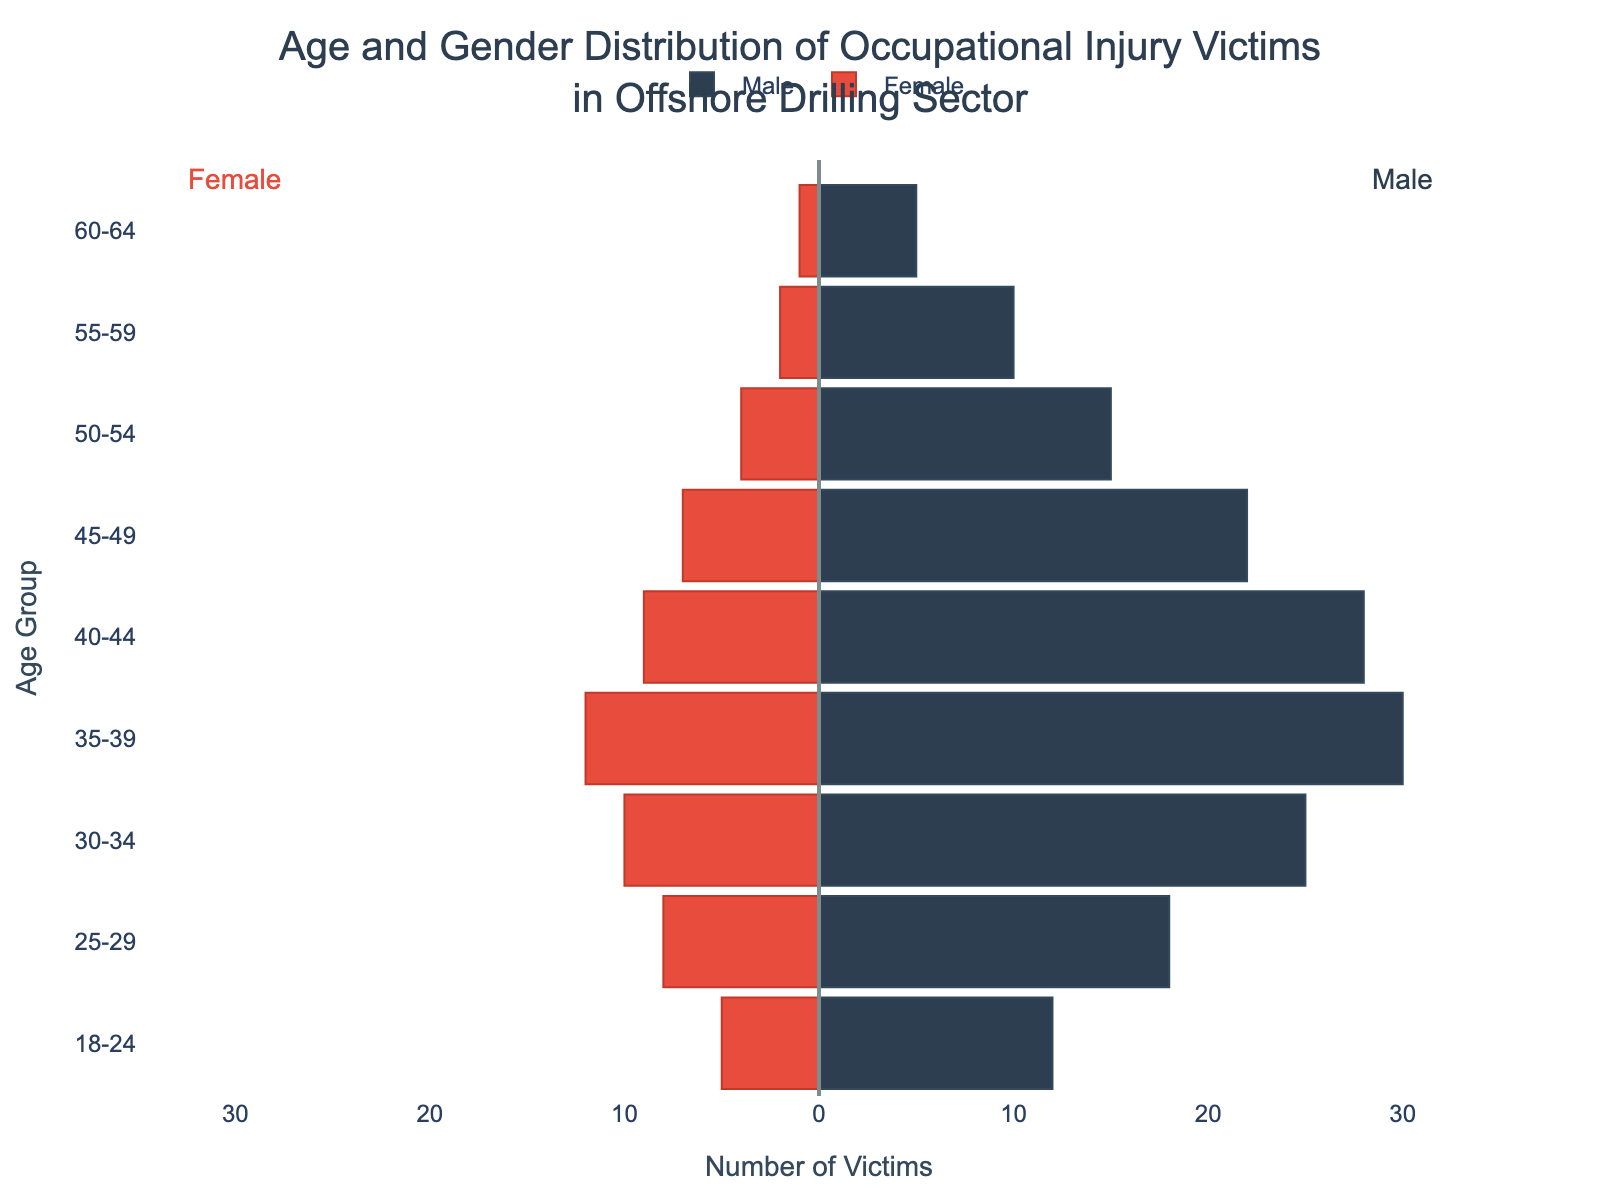What is the title of the chart? The title is the text at the top of the chart, usually larger and bolder than other text.
Answer: Age and Gender Distribution of Occupational Injury Victims in Offshore Drilling Sector How many age groups are represented in the chart? Count the number of distinct age labels on the y-axis.
Answer: 9 Which age group has the highest number of male victims? Look for the bar on the right (male side) with the maximum length and note its corresponding age group.
Answer: 35-39 How many female victims are there in the 25-29 age group? Identify the length of the bar on the left corresponding to the 25-29 age group.
Answer: 8 What is the total number of victims in the 50-54 age group? Add the number of male victims and female victims in the 50-54 age group. Male: 15, Female: 4.
Answer: 19 Compare the number of male and female victims in the 40-44 age group. Which gender has more victims? Subtract the number of female victims from the male victims in the 40-44 age group and determine which is greater (Male: 28, Female: 9).
Answer: Male What is the average number of male victims across all age groups? Sum the number of male victims for all age groups and divide by the number of age groups. (12+18+25+30+28+22+15+10+5) / 9
Answer: 18.33 Is the number of victims higher in the 30-34 or the 55-59 age group? Compare the total number of male and female victims in both age groups. For 30-34: Male: 25, Female: 10. For 55-59: Male: 10, Female: 2. 30-34 total: 35, 55-59 total: 12.
Answer: 30-34 Which side of the chart represents female victims? Identify the side where the bars extend negatively along the x-axis.
Answer: Left What is the difference between the total number of male victims and female victims in the 35-39 age group? Subtract the total number of female victims from the total number of male victims in the 35-39 age group (Male: 30, Female: 12).
Answer: 18 